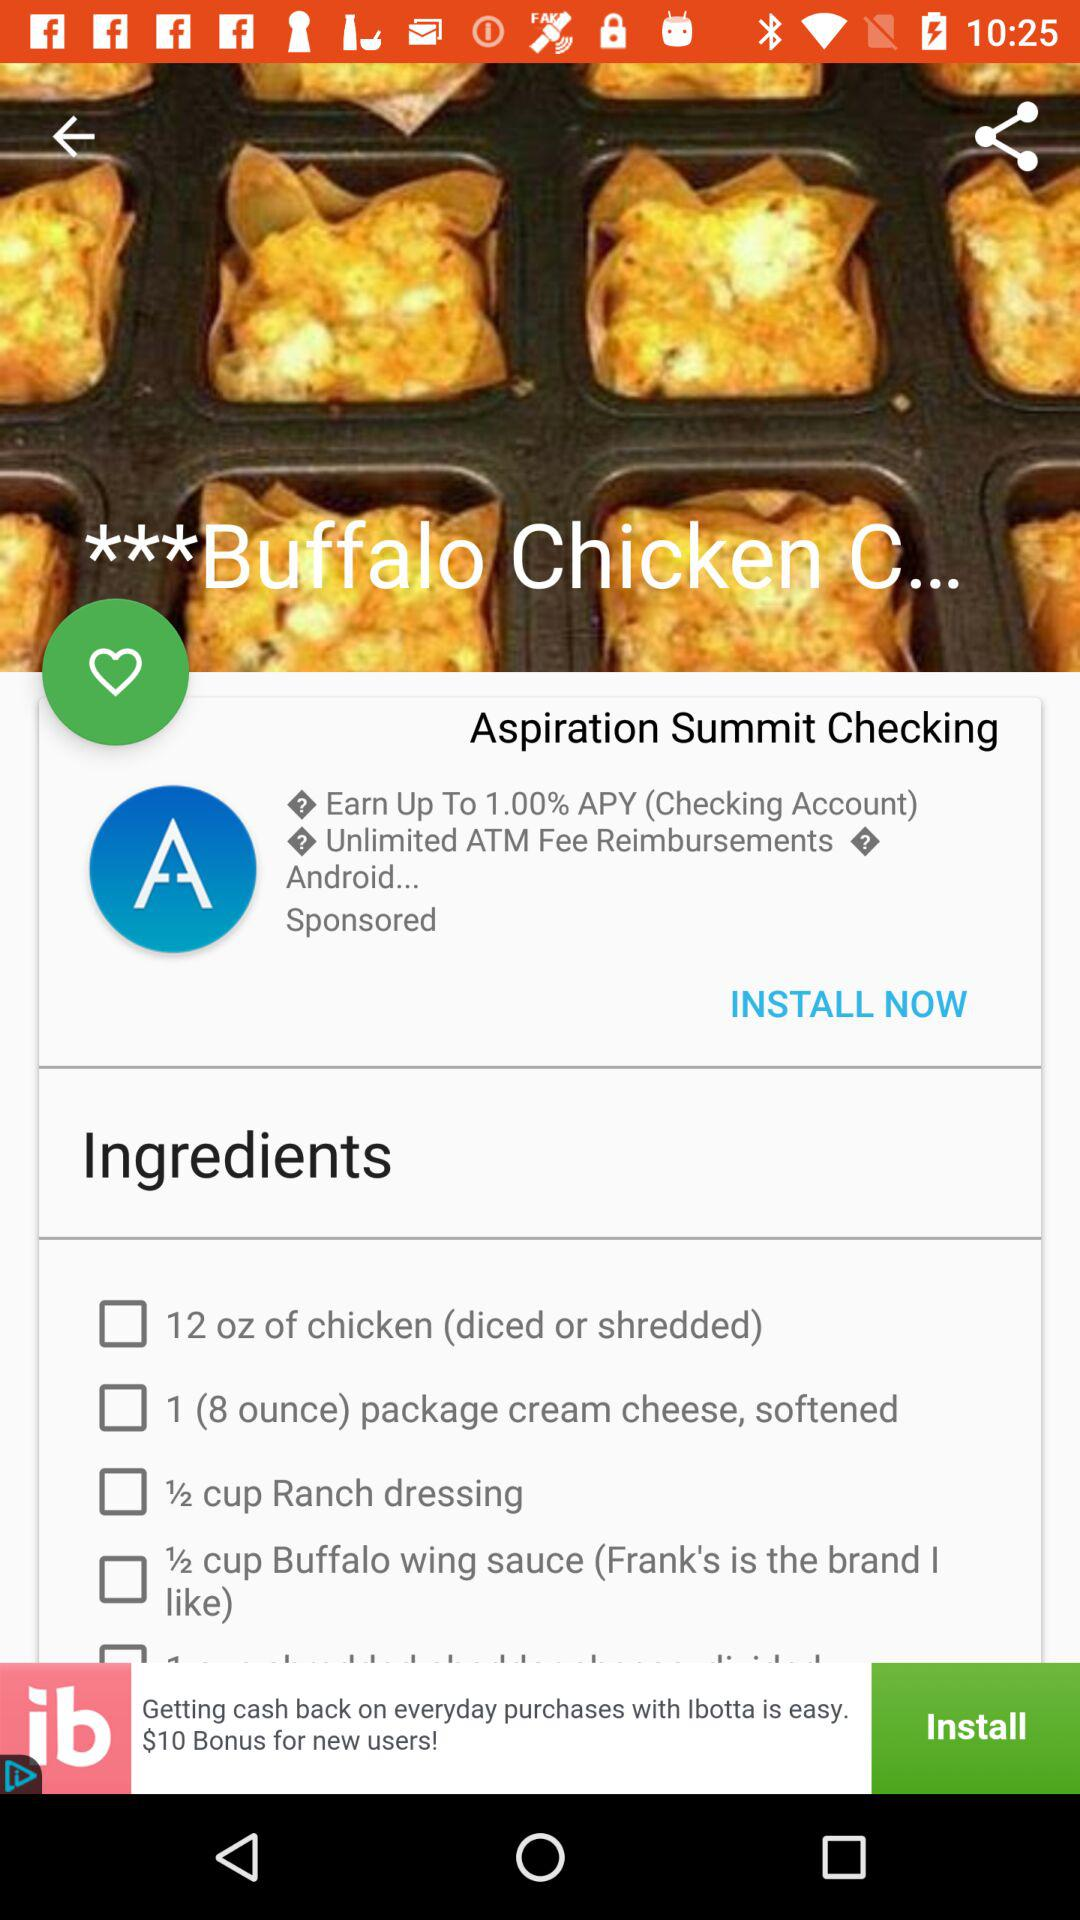How many cups of ranch dressing are required to make Buffalo chicken? It requires half a cup of ranch dressing. 